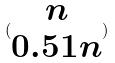<formula> <loc_0><loc_0><loc_500><loc_500>( \begin{matrix} n \\ 0 . 5 1 n \end{matrix} )</formula> 